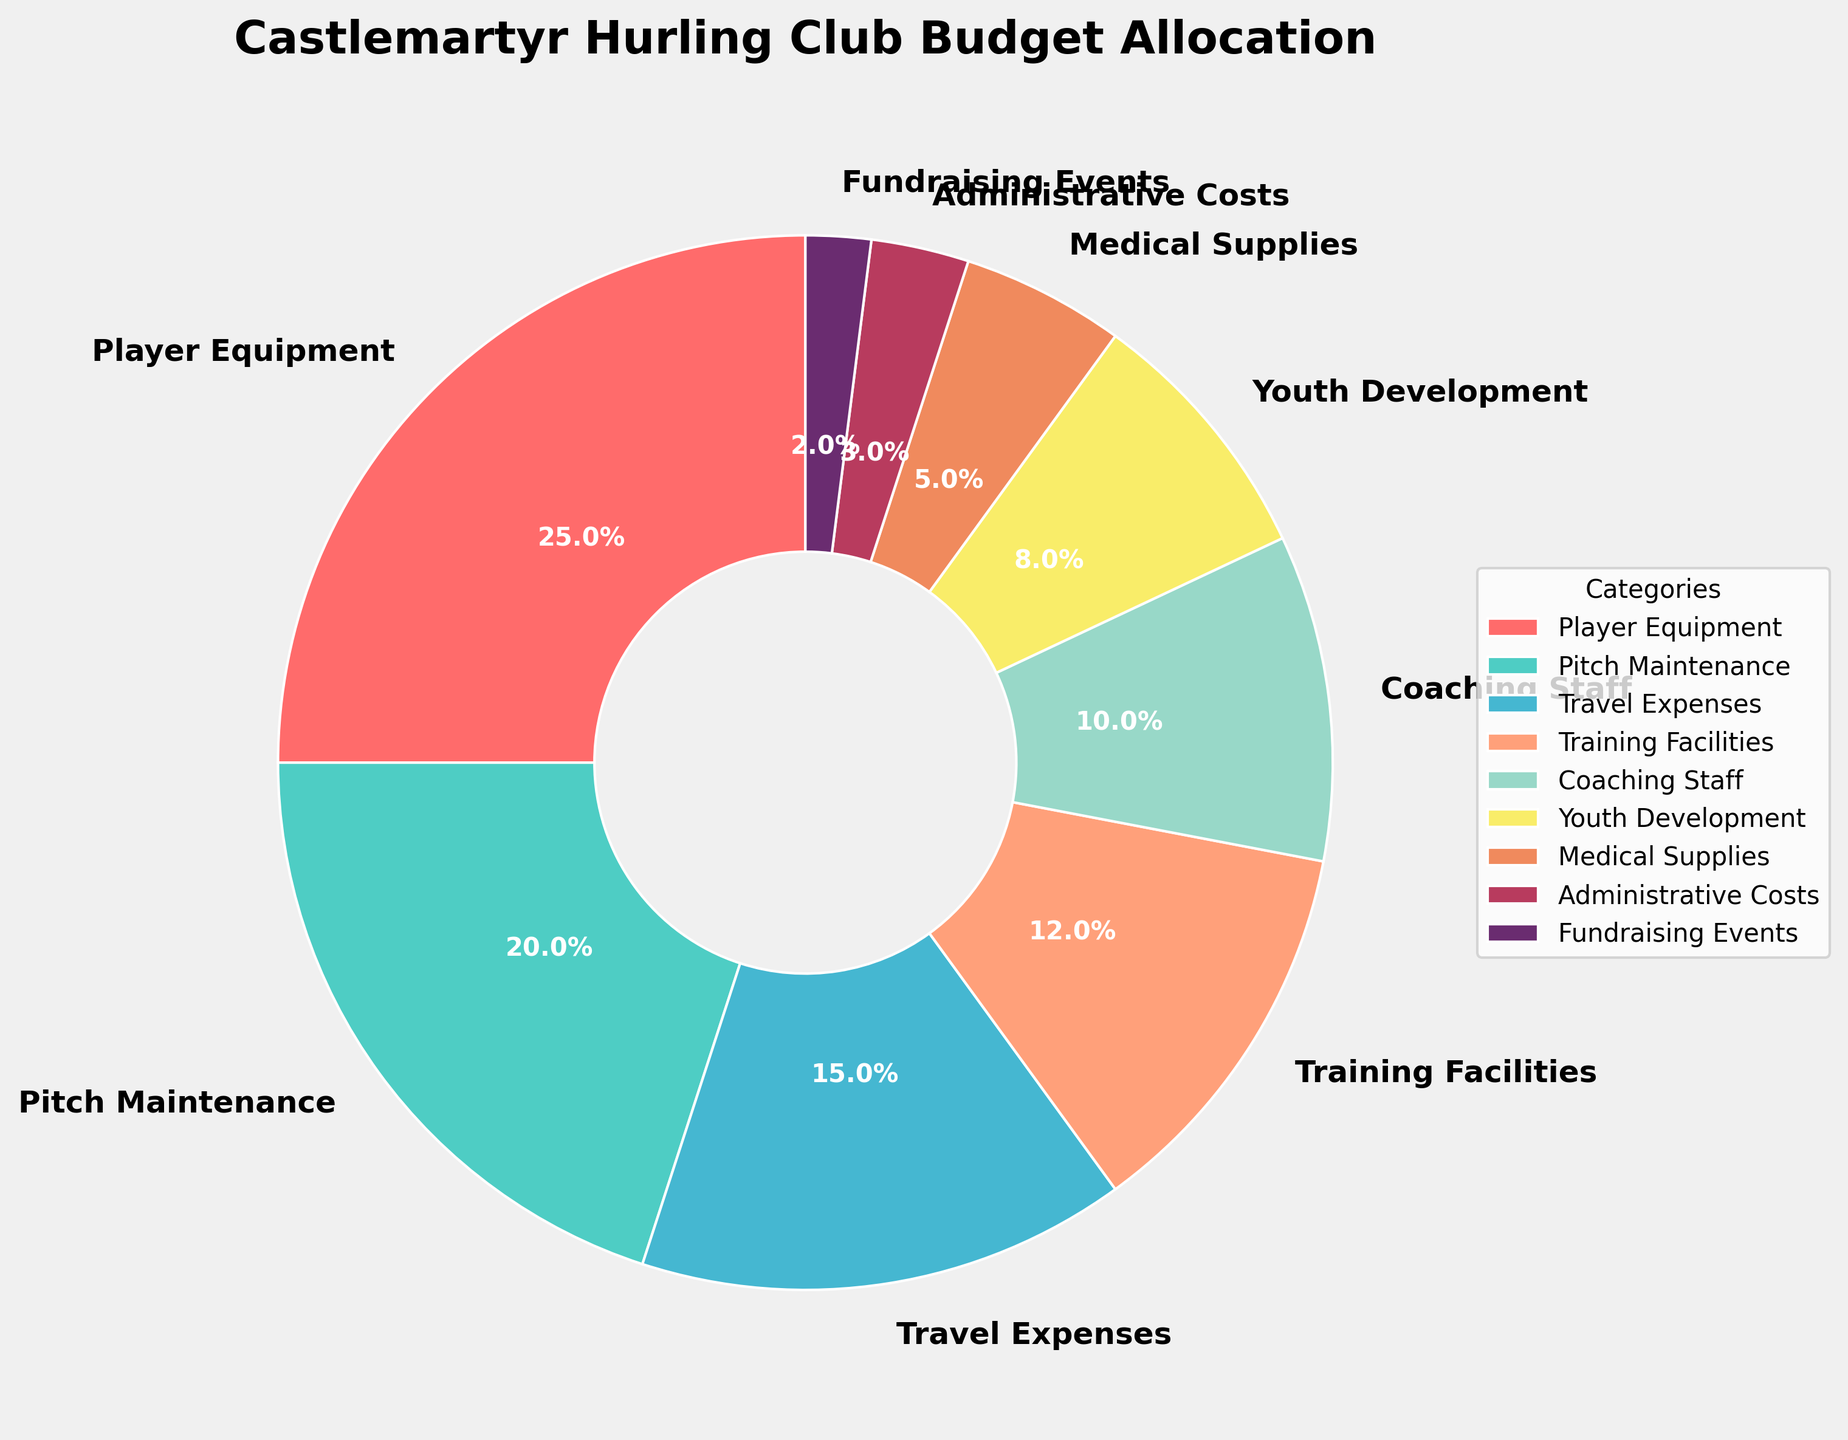What's the largest allocation category in Castlemartyr Hurling Club's budget? The pie chart shows that the largest segment is marked "Player Equipment" with a percentage of 25%.
Answer: Player Equipment Which category has the smallest allocation in the budget? The pie chart shows that the smallest segment is marked "Fundraising Events" with a percentage of 2%.
Answer: Fundraising Events Is the budget for Pitch Maintenance greater than the combined budget for Youth Development and Medical Supplies? The percentage for Pitch Maintenance is 20%. The combined percentage for Youth Development and Medical Supplies is 8% + 5% = 13%. 20% is greater than 13%.
Answer: Yes What's the total percentage allocated to Coaching Staff, Administrative Costs, and Fundraising Events? Add the percentages: 10% (Coaching Staff) + 3% (Administrative Costs) + 2% (Fundraising Events) = 15%.
Answer: 15% How does the budget for Travel Expenses compare to the budget for Training Facilities? Travel Expenses is marked at 15%, while Training Facilities is marked at 12%. 15% is greater than 12%.
Answer: Travel Expenses is higher Which categories combined make up exactly half of the total budget? We need categories that sum up to 50%. Combining Player Equipment (25%), Pitch Maintenance (20%), and Fundraising Events (2%) gives us a total of 47% which does not work. However, combining Player Equipment (25%) and Pitch Maintenance (20%) with Medical Supplies (5%) gives us exactly 50%.
Answer: Player Equipment, Pitch Maintenance, and Medical Supplies Are there more funds allocated to Youth Development or Medical Supplies? Youth Development is marked at 8%, while Medical Supplies is marked at 5%. 8% is greater than 5%.
Answer: Youth Development What's the percentage difference between Player Equipment and Travel Expenses? Player Equipment is 25% and Travel Expenses is 15%. The difference is 25% - 15% = 10%.
Answer: 10% What percentage is allocated to categories related to maintenance and equipment combined? Adding Player Equipment (25%), Pitch Maintenance (20%), and Medical Supplies (5%) results in a combined percentage of 50%.
Answer: 50% 